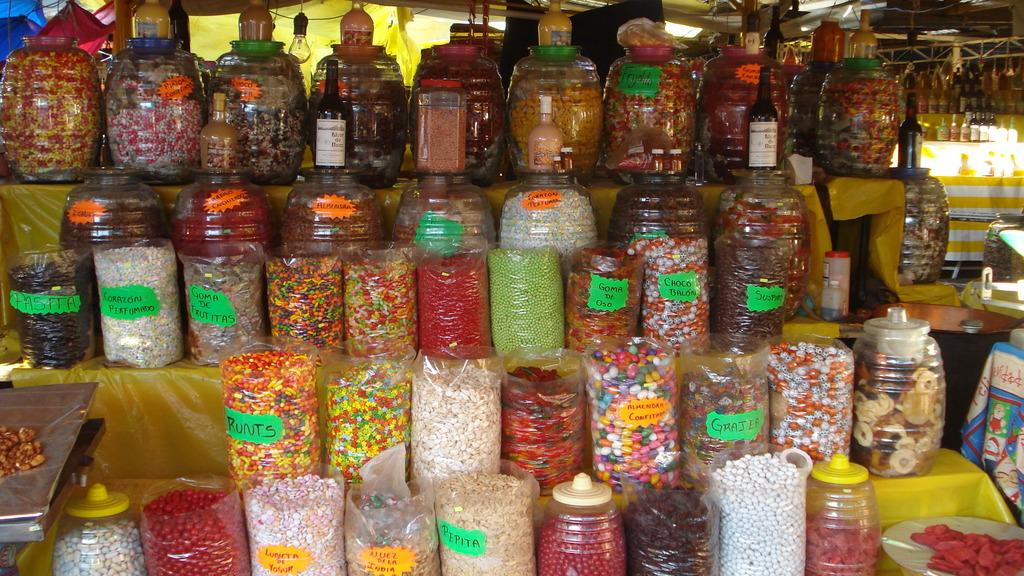What objects can be seen in the image? There are bottles in the image. What is inside the bottles? There are eatable items inside the bottles. What does the father say about the ant in the image? There is no father or ant present in the image, so this question cannot be answered. 